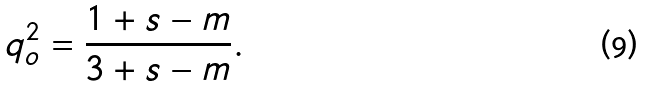Convert formula to latex. <formula><loc_0><loc_0><loc_500><loc_500>q _ { o } ^ { 2 } = \frac { 1 + s - m } { 3 + s - m } .</formula> 